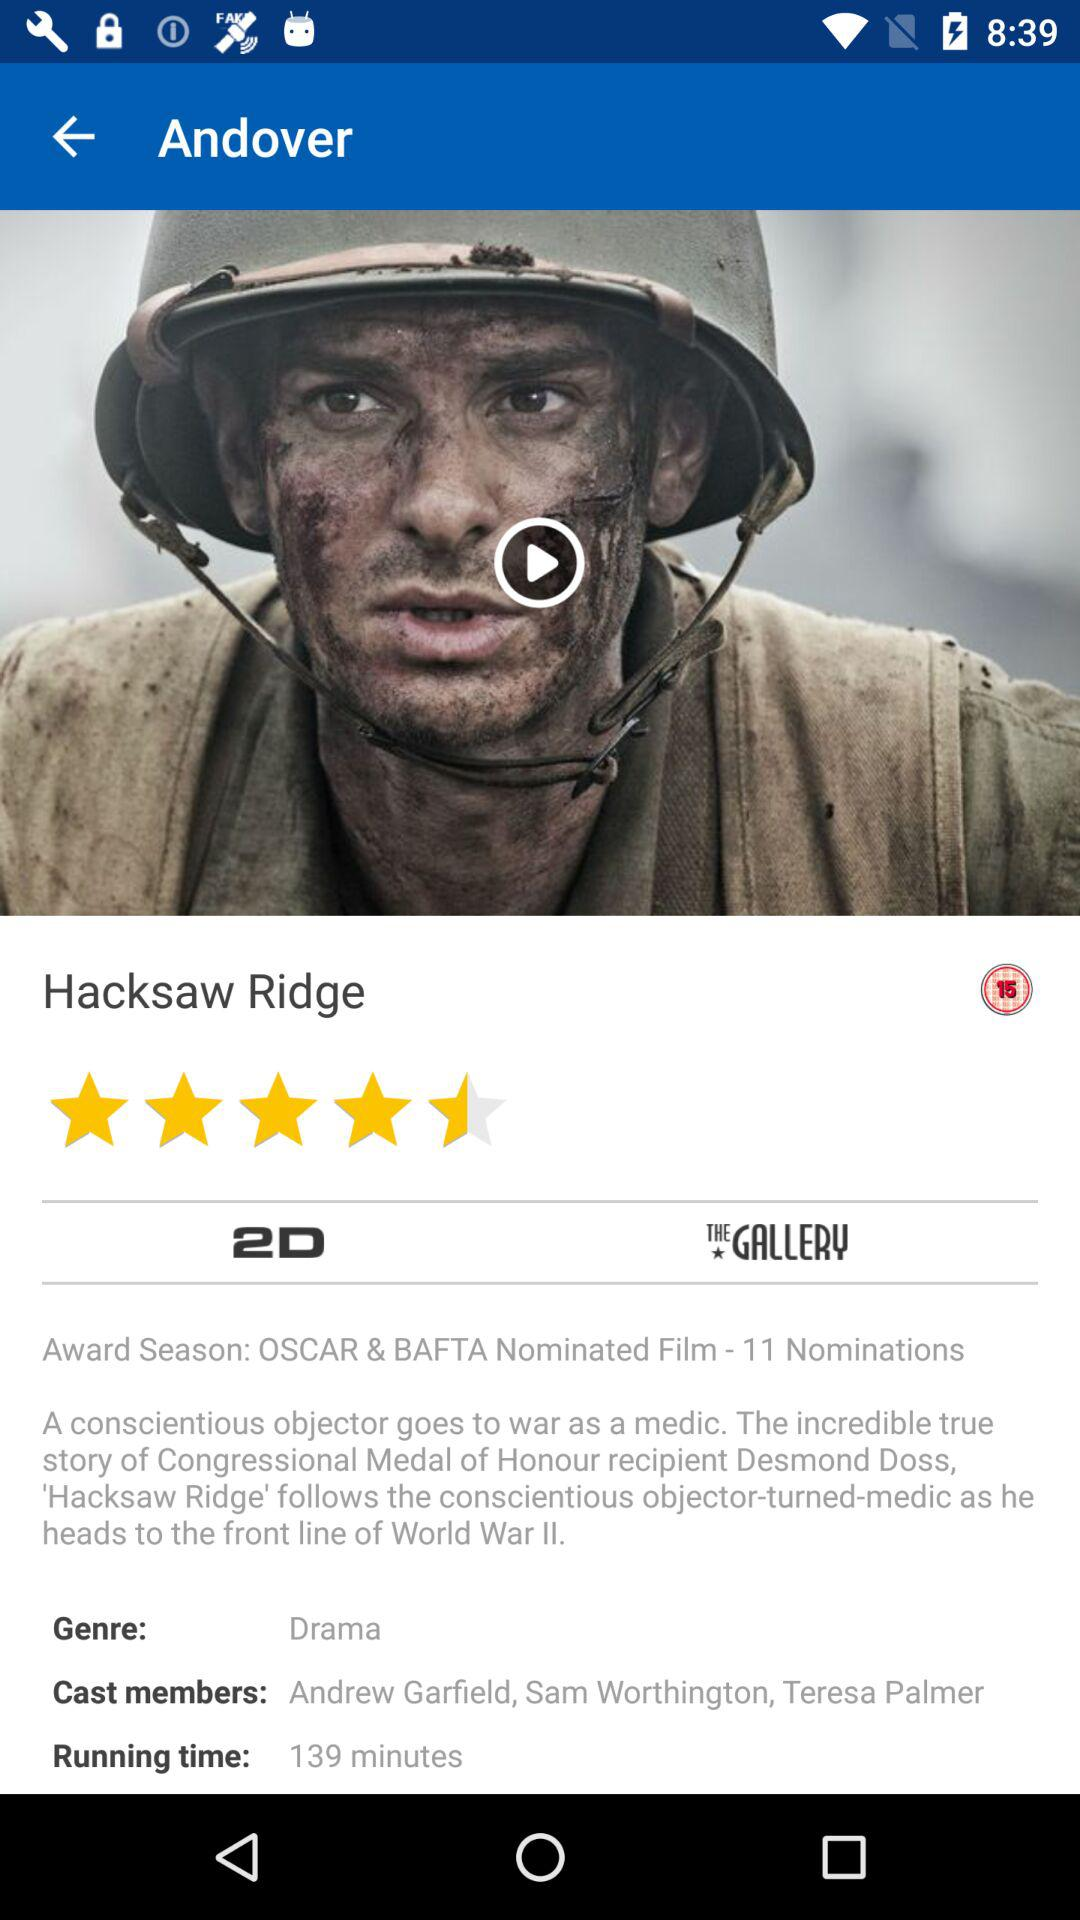What is the genre? The genre is drama. 